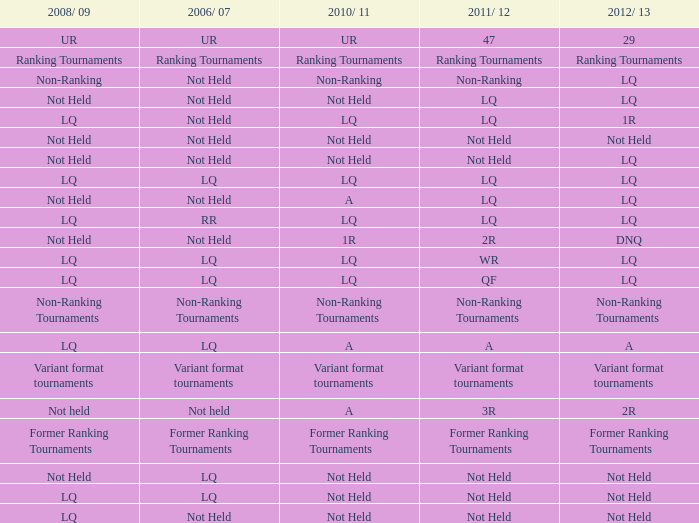What is 2010-11, when 2006/07 is UR? UR. 